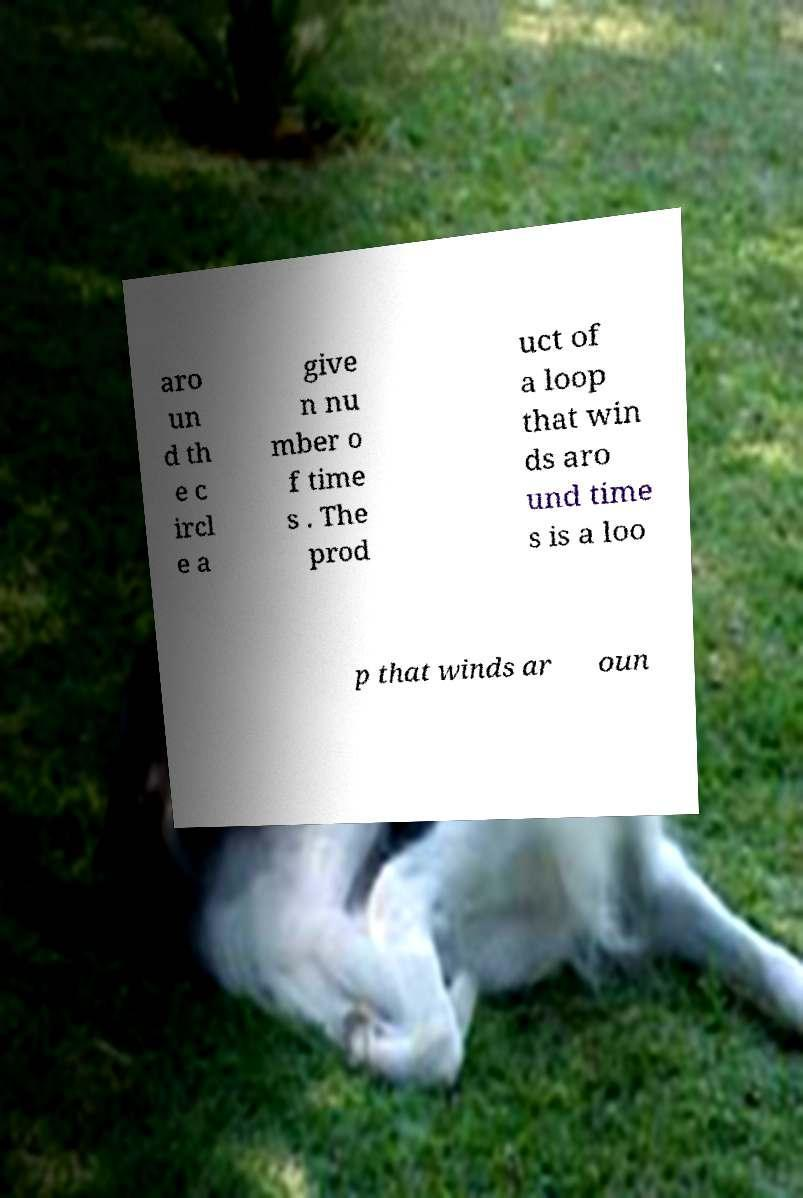Can you accurately transcribe the text from the provided image for me? aro un d th e c ircl e a give n nu mber o f time s . The prod uct of a loop that win ds aro und time s is a loo p that winds ar oun 